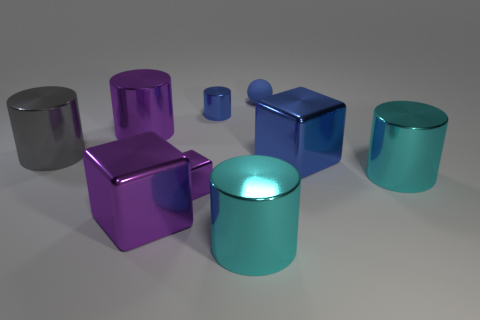Add 1 large cyan metallic things. How many objects exist? 10 Subtract all big cubes. How many cubes are left? 1 Subtract all cyan cylinders. How many cylinders are left? 3 Subtract 1 spheres. How many spheres are left? 0 Subtract all cubes. How many objects are left? 6 Subtract all red spheres. How many blue blocks are left? 1 Subtract all brown cubes. Subtract all yellow cylinders. How many cubes are left? 3 Subtract all big shiny cylinders. Subtract all gray rubber cylinders. How many objects are left? 5 Add 6 purple shiny cubes. How many purple shiny cubes are left? 8 Add 5 matte spheres. How many matte spheres exist? 6 